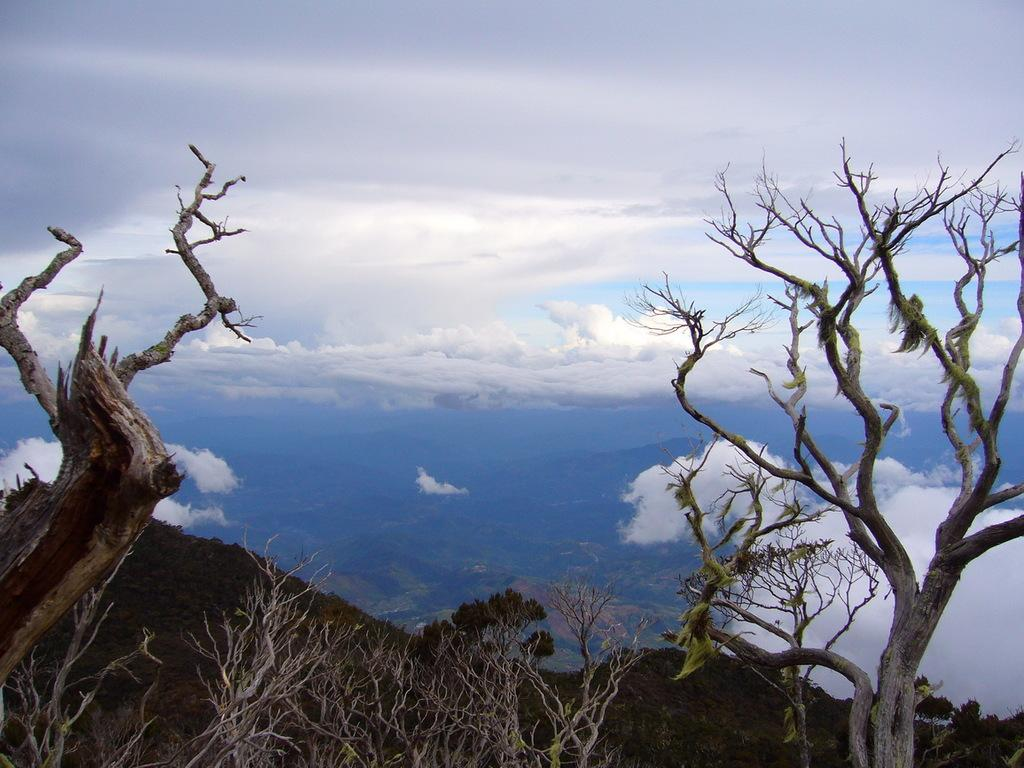What type of trees are visible in the image? There are bare trees in the image. What can be seen in the distance behind the trees? There are mountains in the background of the image. What is visible in the sky in the background of the image? There are clouds in the sky in the background of the image. What flavor of mint is growing near the trees in the image? There is no mint present in the image; it only features bare trees, mountains, and clouds. 